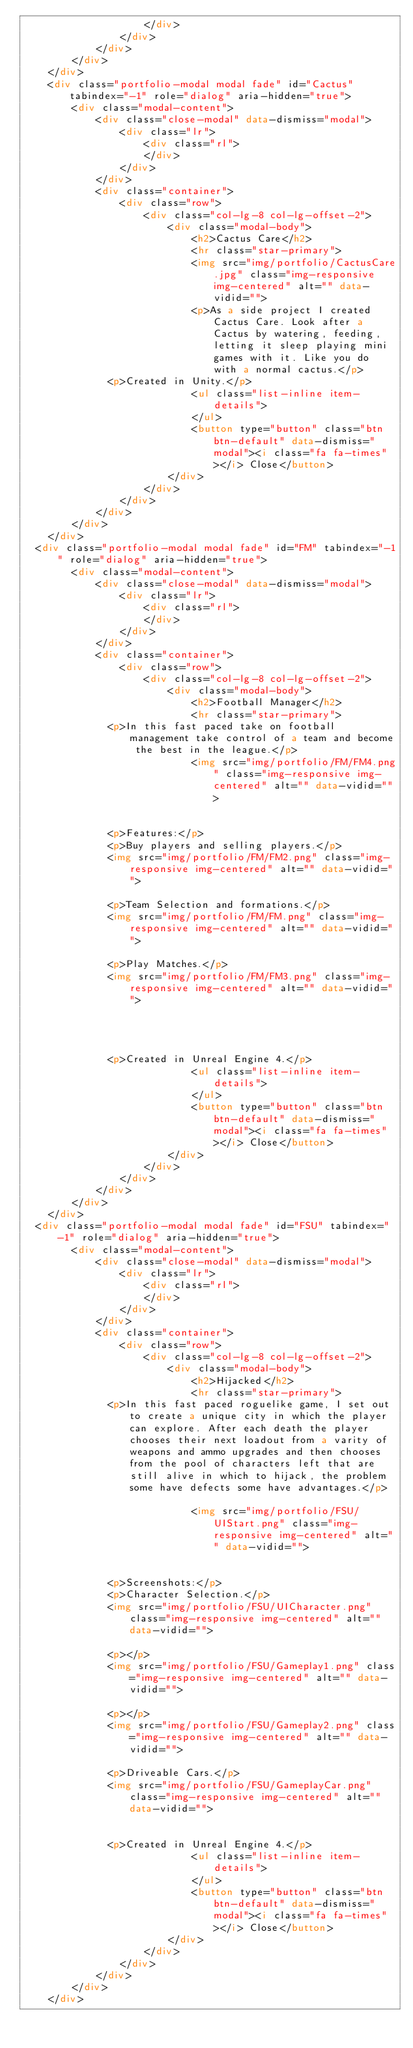Convert code to text. <code><loc_0><loc_0><loc_500><loc_500><_HTML_>                    </div>
                </div>
            </div>
        </div>
    </div>
    <div class="portfolio-modal modal fade" id="Cactus" tabindex="-1" role="dialog" aria-hidden="true">
        <div class="modal-content">
            <div class="close-modal" data-dismiss="modal">
                <div class="lr">
                    <div class="rl">
                    </div>
                </div>
            </div>
            <div class="container">
                <div class="row">
                    <div class="col-lg-8 col-lg-offset-2">
                        <div class="modal-body">
                            <h2>Cactus Care</h2>
                            <hr class="star-primary">
                            <img src="img/portfolio/CactusCare.jpg" class="img-responsive img-centered" alt="" data-vidid="">
                            <p>As a side project I created Cactus Care. Look after a Cactus by watering, feeding, letting it sleep playing mini games with it. Like you do with a normal cactus.</p>
							<p>Created in Unity.</p>
                            <ul class="list-inline item-details">
                            </ul>
                            <button type="button" class="btn btn-default" data-dismiss="modal"><i class="fa fa-times"></i> Close</button>
                        </div>
                    </div>
                </div>
            </div>
        </div>
    </div>
	<div class="portfolio-modal modal fade" id="FM" tabindex="-1" role="dialog" aria-hidden="true">
        <div class="modal-content">
            <div class="close-modal" data-dismiss="modal">
                <div class="lr">
                    <div class="rl">
                    </div>
                </div>
            </div>
            <div class="container">
                <div class="row">
                    <div class="col-lg-8 col-lg-offset-2">
                        <div class="modal-body">
                            <h2>Football Manager</h2>
                            <hr class="star-primary">
							<p>In this fast paced take on football management take control of a team and become the best in the league.</p>
                            <img src="img/portfolio/FM/FM4.png" class="img-responsive img-centered" alt="" data-vidid="">
                            
							
							<p>Features:</p>
							<p>Buy players and selling players.</p>
							<img src="img/portfolio/FM/FM2.png" class="img-responsive img-centered" alt="" data-vidid="">							
							
							<p>Team Selection and formations.</p>
							<img src="img/portfolio/FM/FM.png" class="img-responsive img-centered" alt="" data-vidid="">		
							
							<p>Play Matches.</p>
							<img src="img/portfolio/FM/FM3.png" class="img-responsive img-centered" alt="" data-vidid="">
							
							
							
							
							<p>Created in Unreal Engine 4.</p>
                            <ul class="list-inline item-details">
                            </ul>
                            <button type="button" class="btn btn-default" data-dismiss="modal"><i class="fa fa-times"></i> Close</button>
                        </div>
                    </div>
                </div>
            </div>
        </div>
    </div>
	<div class="portfolio-modal modal fade" id="FSU" tabindex="-1" role="dialog" aria-hidden="true">
        <div class="modal-content">
            <div class="close-modal" data-dismiss="modal">
                <div class="lr">
                    <div class="rl">
                    </div>
                </div>
            </div>
            <div class="container">
                <div class="row">
                    <div class="col-lg-8 col-lg-offset-2">
                        <div class="modal-body">
                            <h2>Hijacked</h2>
                            <hr class="star-primary">
							<p>In this fast paced roguelike game, I set out to create a unique city in which the player can explore. After each death the player chooses their next loadout from a varity of weapons and ammo upgrades and then chooses from the pool of characters left that are still alive in which to hijack, the problem some have defects some have advantages.</p>
							
                            <img src="img/portfolio/FSU/UIStart.png" class="img-responsive img-centered" alt="" data-vidid="">
                            
							
							<p>Screenshots:</p>
							<p>Character Selection.</p>
							<img src="img/portfolio/FSU/UICharacter.png" class="img-responsive img-centered" alt="" data-vidid="">							
							
							<p></p>
							<img src="img/portfolio/FSU/Gameplay1.png" class="img-responsive img-centered" alt="" data-vidid="">		
							
							<p></p>
							<img src="img/portfolio/FSU/Gameplay2.png" class="img-responsive img-centered" alt="" data-vidid="">
							
							<p>Driveable Cars.</p>
							<img src="img/portfolio/FSU/GameplayCar.png" class="img-responsive img-centered" alt="" data-vidid="">
							
							
							<p>Created in Unreal Engine 4.</p>
                            <ul class="list-inline item-details">
                            </ul>
                            <button type="button" class="btn btn-default" data-dismiss="modal"><i class="fa fa-times"></i> Close</button>
                        </div>
                    </div>
                </div>
            </div>
        </div>
    </div></code> 